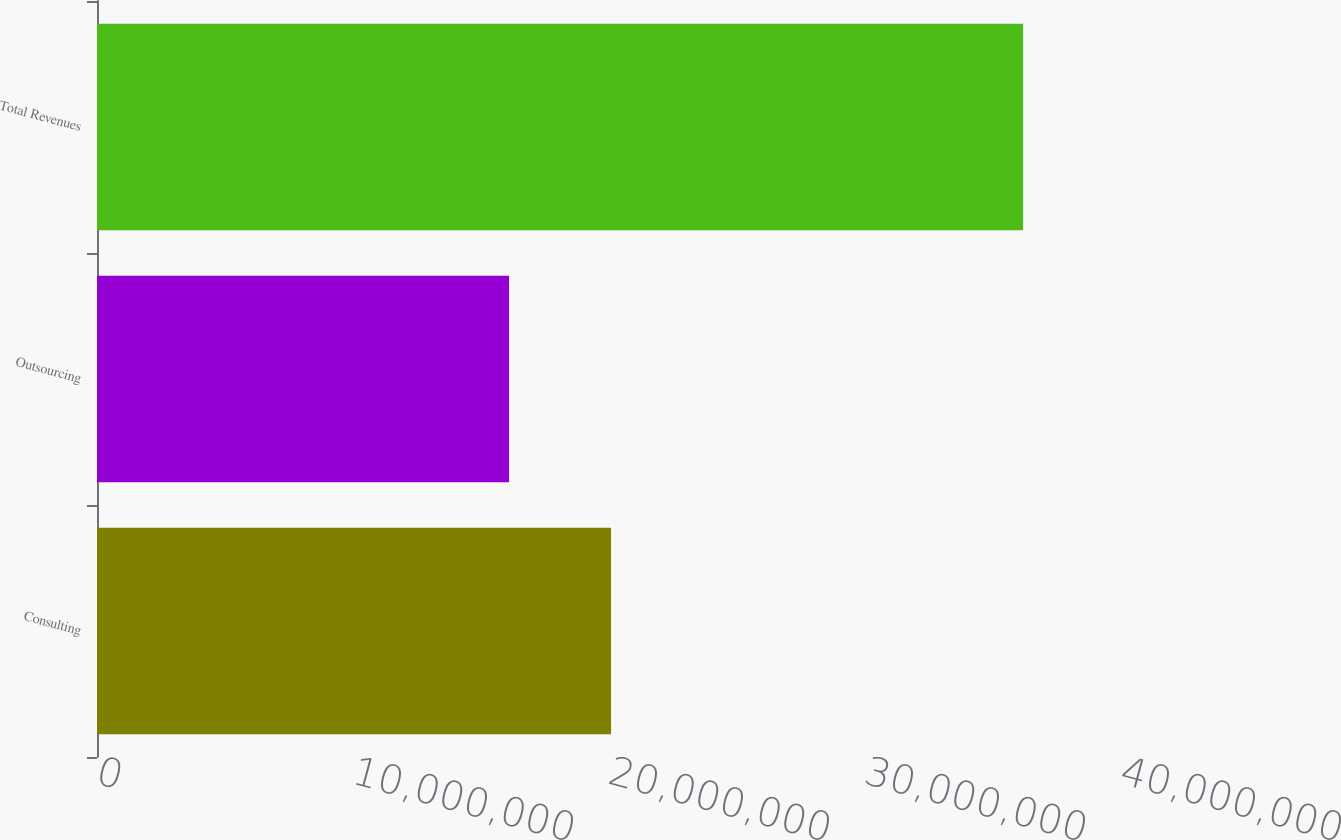Convert chart to OTSL. <chart><loc_0><loc_0><loc_500><loc_500><bar_chart><fcel>Consulting<fcel>Outsourcing<fcel>Total Revenues<nl><fcel>2.00805e+07<fcel>1.60964e+07<fcel>3.61768e+07<nl></chart> 